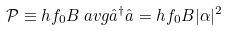Convert formula to latex. <formula><loc_0><loc_0><loc_500><loc_500>\mathcal { P } & \equiv h f _ { 0 } B \ a v g { \hat { a } ^ { \dagger } \hat { a } } = h f _ { 0 } B | \alpha | ^ { 2 }</formula> 